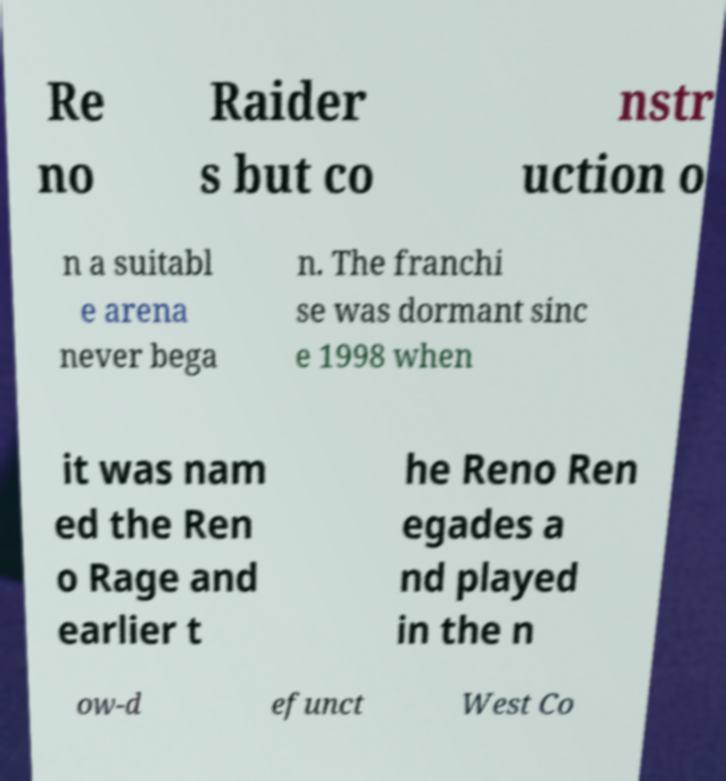Please read and relay the text visible in this image. What does it say? Re no Raider s but co nstr uction o n a suitabl e arena never bega n. The franchi se was dormant sinc e 1998 when it was nam ed the Ren o Rage and earlier t he Reno Ren egades a nd played in the n ow-d efunct West Co 